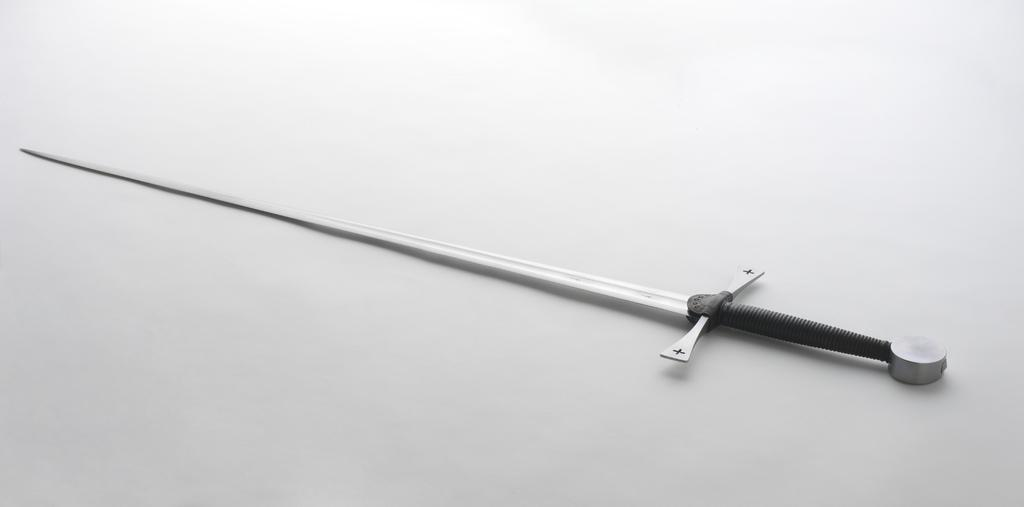What type of picture is in the image? The image contains a black and white picture. What is the subject of the picture? The picture depicts a sword. Where is the sword located in the image? The sword is placed on a surface. What type of liquid is being poured from the cart in the image? There is no cart or liquid present in the image; it only contains a black and white picture of a sword placed on a surface. 